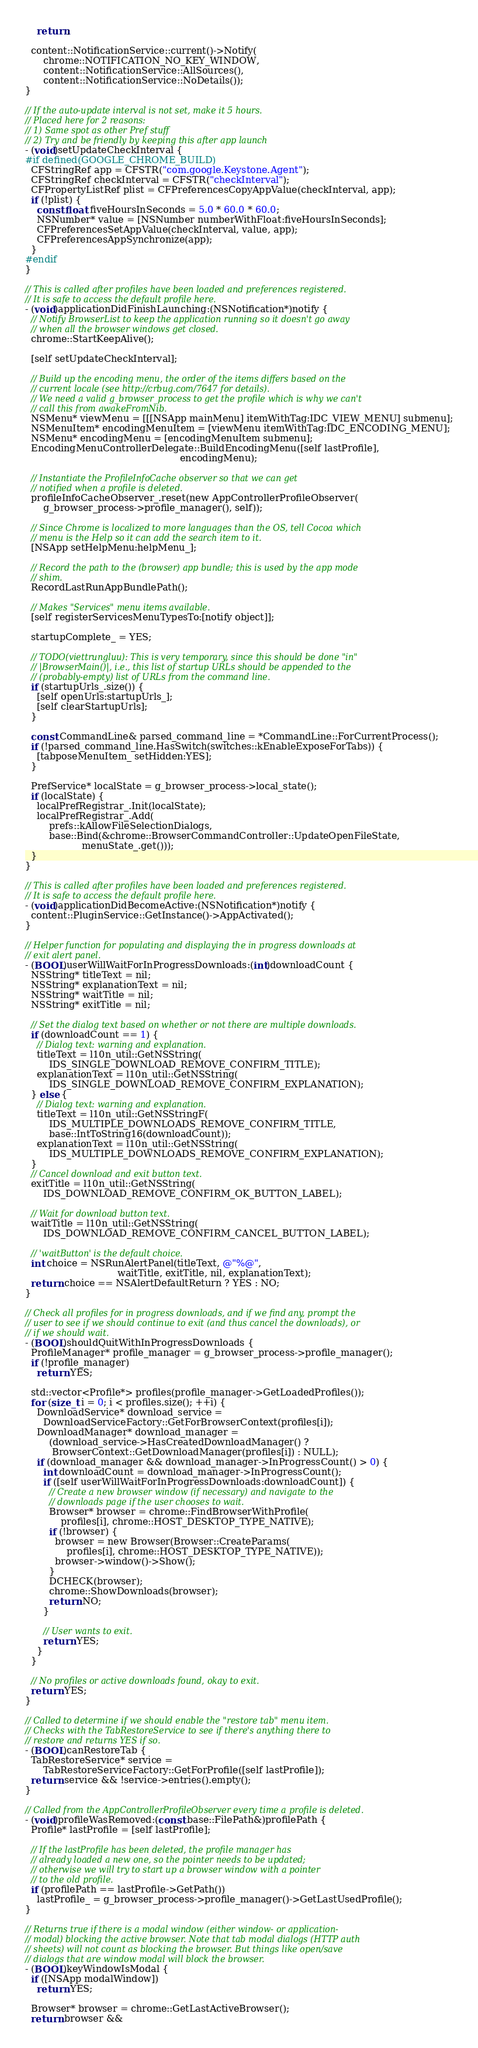<code> <loc_0><loc_0><loc_500><loc_500><_ObjectiveC_>    return;

  content::NotificationService::current()->Notify(
      chrome::NOTIFICATION_NO_KEY_WINDOW,
      content::NotificationService::AllSources(),
      content::NotificationService::NoDetails());
}

// If the auto-update interval is not set, make it 5 hours.
// Placed here for 2 reasons:
// 1) Same spot as other Pref stuff
// 2) Try and be friendly by keeping this after app launch
- (void)setUpdateCheckInterval {
#if defined(GOOGLE_CHROME_BUILD)
  CFStringRef app = CFSTR("com.google.Keystone.Agent");
  CFStringRef checkInterval = CFSTR("checkInterval");
  CFPropertyListRef plist = CFPreferencesCopyAppValue(checkInterval, app);
  if (!plist) {
    const float fiveHoursInSeconds = 5.0 * 60.0 * 60.0;
    NSNumber* value = [NSNumber numberWithFloat:fiveHoursInSeconds];
    CFPreferencesSetAppValue(checkInterval, value, app);
    CFPreferencesAppSynchronize(app);
  }
#endif
}

// This is called after profiles have been loaded and preferences registered.
// It is safe to access the default profile here.
- (void)applicationDidFinishLaunching:(NSNotification*)notify {
  // Notify BrowserList to keep the application running so it doesn't go away
  // when all the browser windows get closed.
  chrome::StartKeepAlive();

  [self setUpdateCheckInterval];

  // Build up the encoding menu, the order of the items differs based on the
  // current locale (see http://crbug.com/7647 for details).
  // We need a valid g_browser_process to get the profile which is why we can't
  // call this from awakeFromNib.
  NSMenu* viewMenu = [[[NSApp mainMenu] itemWithTag:IDC_VIEW_MENU] submenu];
  NSMenuItem* encodingMenuItem = [viewMenu itemWithTag:IDC_ENCODING_MENU];
  NSMenu* encodingMenu = [encodingMenuItem submenu];
  EncodingMenuControllerDelegate::BuildEncodingMenu([self lastProfile],
                                                    encodingMenu);

  // Instantiate the ProfileInfoCache observer so that we can get
  // notified when a profile is deleted.
  profileInfoCacheObserver_.reset(new AppControllerProfileObserver(
      g_browser_process->profile_manager(), self));

  // Since Chrome is localized to more languages than the OS, tell Cocoa which
  // menu is the Help so it can add the search item to it.
  [NSApp setHelpMenu:helpMenu_];

  // Record the path to the (browser) app bundle; this is used by the app mode
  // shim.
  RecordLastRunAppBundlePath();

  // Makes "Services" menu items available.
  [self registerServicesMenuTypesTo:[notify object]];

  startupComplete_ = YES;

  // TODO(viettrungluu): This is very temporary, since this should be done "in"
  // |BrowserMain()|, i.e., this list of startup URLs should be appended to the
  // (probably-empty) list of URLs from the command line.
  if (startupUrls_.size()) {
    [self openUrls:startupUrls_];
    [self clearStartupUrls];
  }

  const CommandLine& parsed_command_line = *CommandLine::ForCurrentProcess();
  if (!parsed_command_line.HasSwitch(switches::kEnableExposeForTabs)) {
    [tabposeMenuItem_ setHidden:YES];
  }

  PrefService* localState = g_browser_process->local_state();
  if (localState) {
    localPrefRegistrar_.Init(localState);
    localPrefRegistrar_.Add(
        prefs::kAllowFileSelectionDialogs,
        base::Bind(&chrome::BrowserCommandController::UpdateOpenFileState,
                   menuState_.get()));
  }
}

// This is called after profiles have been loaded and preferences registered.
// It is safe to access the default profile here.
- (void)applicationDidBecomeActive:(NSNotification*)notify {
  content::PluginService::GetInstance()->AppActivated();
}

// Helper function for populating and displaying the in progress downloads at
// exit alert panel.
- (BOOL)userWillWaitForInProgressDownloads:(int)downloadCount {
  NSString* titleText = nil;
  NSString* explanationText = nil;
  NSString* waitTitle = nil;
  NSString* exitTitle = nil;

  // Set the dialog text based on whether or not there are multiple downloads.
  if (downloadCount == 1) {
    // Dialog text: warning and explanation.
    titleText = l10n_util::GetNSString(
        IDS_SINGLE_DOWNLOAD_REMOVE_CONFIRM_TITLE);
    explanationText = l10n_util::GetNSString(
        IDS_SINGLE_DOWNLOAD_REMOVE_CONFIRM_EXPLANATION);
  } else {
    // Dialog text: warning and explanation.
    titleText = l10n_util::GetNSStringF(
        IDS_MULTIPLE_DOWNLOADS_REMOVE_CONFIRM_TITLE,
        base::IntToString16(downloadCount));
    explanationText = l10n_util::GetNSString(
        IDS_MULTIPLE_DOWNLOADS_REMOVE_CONFIRM_EXPLANATION);
  }
  // Cancel download and exit button text.
  exitTitle = l10n_util::GetNSString(
      IDS_DOWNLOAD_REMOVE_CONFIRM_OK_BUTTON_LABEL);

  // Wait for download button text.
  waitTitle = l10n_util::GetNSString(
      IDS_DOWNLOAD_REMOVE_CONFIRM_CANCEL_BUTTON_LABEL);

  // 'waitButton' is the default choice.
  int choice = NSRunAlertPanel(titleText, @"%@",
                               waitTitle, exitTitle, nil, explanationText);
  return choice == NSAlertDefaultReturn ? YES : NO;
}

// Check all profiles for in progress downloads, and if we find any, prompt the
// user to see if we should continue to exit (and thus cancel the downloads), or
// if we should wait.
- (BOOL)shouldQuitWithInProgressDownloads {
  ProfileManager* profile_manager = g_browser_process->profile_manager();
  if (!profile_manager)
    return YES;

  std::vector<Profile*> profiles(profile_manager->GetLoadedProfiles());
  for (size_t i = 0; i < profiles.size(); ++i) {
    DownloadService* download_service =
      DownloadServiceFactory::GetForBrowserContext(profiles[i]);
    DownloadManager* download_manager =
        (download_service->HasCreatedDownloadManager() ?
         BrowserContext::GetDownloadManager(profiles[i]) : NULL);
    if (download_manager && download_manager->InProgressCount() > 0) {
      int downloadCount = download_manager->InProgressCount();
      if ([self userWillWaitForInProgressDownloads:downloadCount]) {
        // Create a new browser window (if necessary) and navigate to the
        // downloads page if the user chooses to wait.
        Browser* browser = chrome::FindBrowserWithProfile(
            profiles[i], chrome::HOST_DESKTOP_TYPE_NATIVE);
        if (!browser) {
          browser = new Browser(Browser::CreateParams(
              profiles[i], chrome::HOST_DESKTOP_TYPE_NATIVE));
          browser->window()->Show();
        }
        DCHECK(browser);
        chrome::ShowDownloads(browser);
        return NO;
      }

      // User wants to exit.
      return YES;
    }
  }

  // No profiles or active downloads found, okay to exit.
  return YES;
}

// Called to determine if we should enable the "restore tab" menu item.
// Checks with the TabRestoreService to see if there's anything there to
// restore and returns YES if so.
- (BOOL)canRestoreTab {
  TabRestoreService* service =
      TabRestoreServiceFactory::GetForProfile([self lastProfile]);
  return service && !service->entries().empty();
}

// Called from the AppControllerProfileObserver every time a profile is deleted.
- (void)profileWasRemoved:(const base::FilePath&)profilePath {
  Profile* lastProfile = [self lastProfile];

  // If the lastProfile has been deleted, the profile manager has
  // already loaded a new one, so the pointer needs to be updated;
  // otherwise we will try to start up a browser window with a pointer
  // to the old profile.
  if (profilePath == lastProfile->GetPath())
    lastProfile_ = g_browser_process->profile_manager()->GetLastUsedProfile();
}

// Returns true if there is a modal window (either window- or application-
// modal) blocking the active browser. Note that tab modal dialogs (HTTP auth
// sheets) will not count as blocking the browser. But things like open/save
// dialogs that are window modal will block the browser.
- (BOOL)keyWindowIsModal {
  if ([NSApp modalWindow])
    return YES;

  Browser* browser = chrome::GetLastActiveBrowser();
  return browser &&</code> 